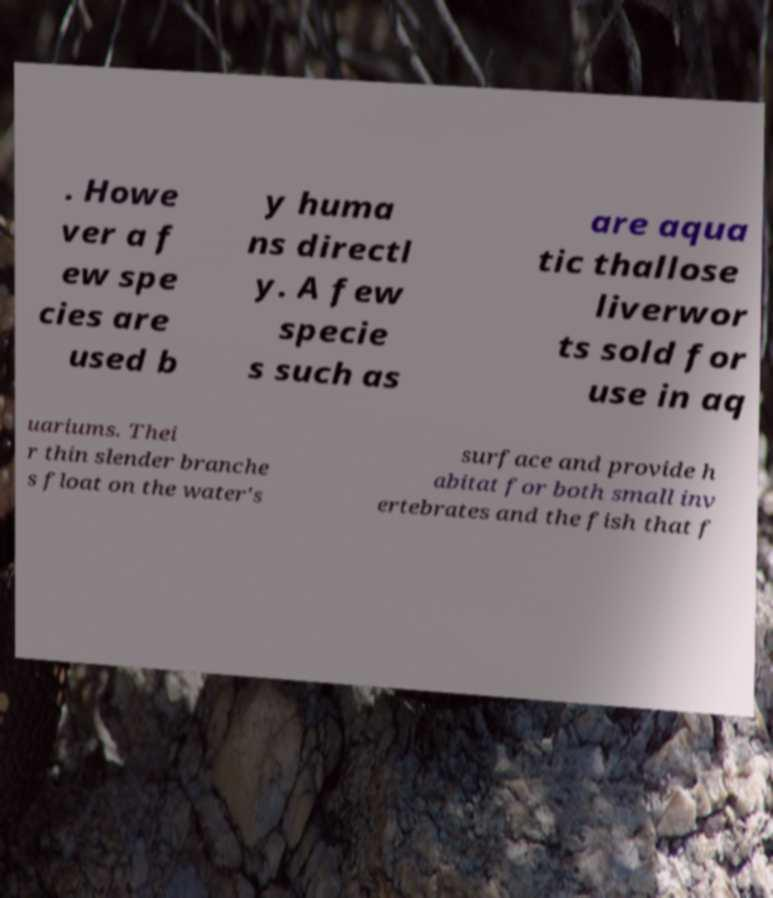Could you assist in decoding the text presented in this image and type it out clearly? . Howe ver a f ew spe cies are used b y huma ns directl y. A few specie s such as are aqua tic thallose liverwor ts sold for use in aq uariums. Thei r thin slender branche s float on the water's surface and provide h abitat for both small inv ertebrates and the fish that f 